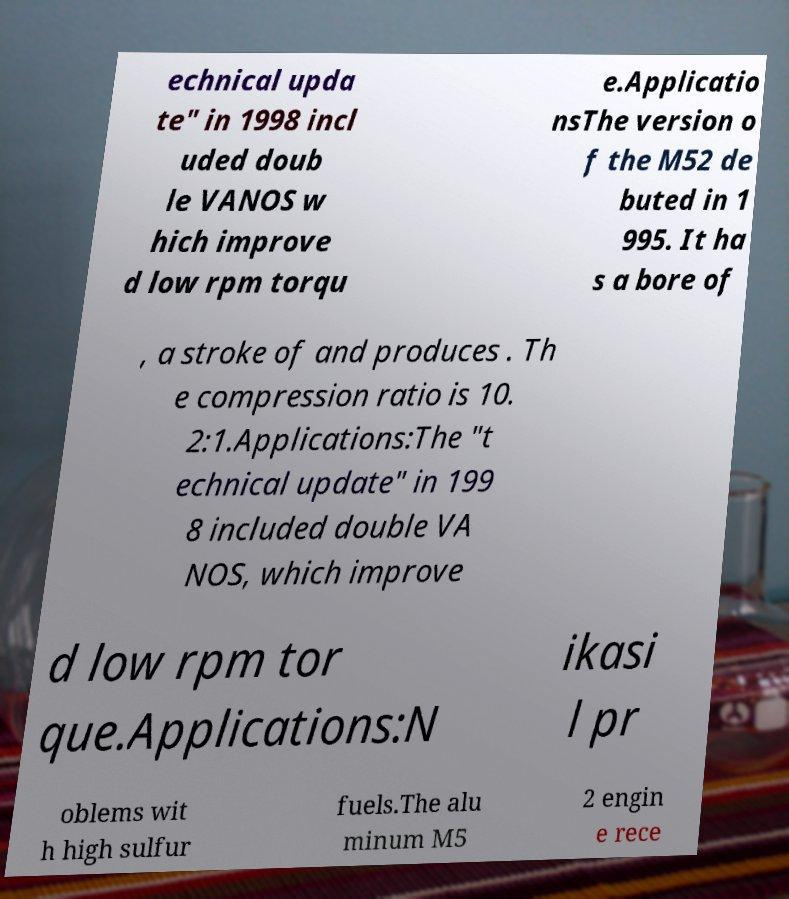Can you accurately transcribe the text from the provided image for me? echnical upda te" in 1998 incl uded doub le VANOS w hich improve d low rpm torqu e.Applicatio nsThe version o f the M52 de buted in 1 995. It ha s a bore of , a stroke of and produces . Th e compression ratio is 10. 2:1.Applications:The "t echnical update" in 199 8 included double VA NOS, which improve d low rpm tor que.Applications:N ikasi l pr oblems wit h high sulfur fuels.The alu minum M5 2 engin e rece 